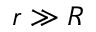<formula> <loc_0><loc_0><loc_500><loc_500>r \gg R</formula> 